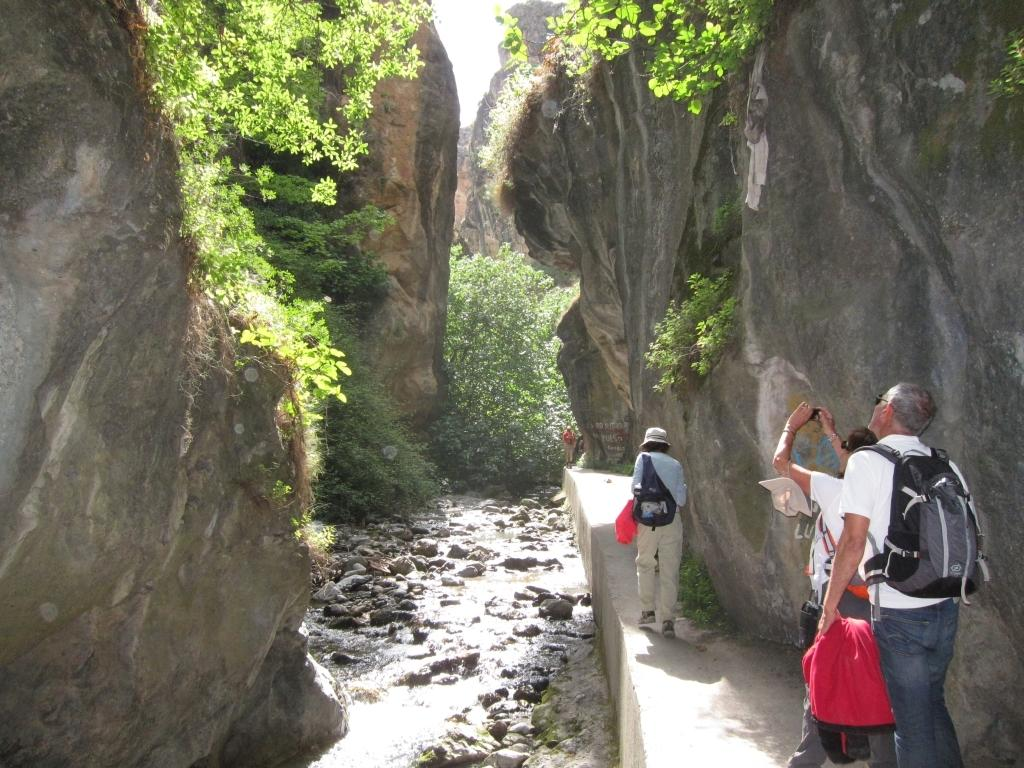What type of natural formations can be seen in the image? There are rock hills in the image. What other natural elements are present in the image? There are plants, stones, and trees in the image. Are there any signs of human presence in the image? Yes, there are people visible on a path in the image. What can be seen in the sky in the image? The sky is visible in the image. What type of popcorn is being sold by the vendor in the image? There is no vendor or popcorn present in the image. How much payment is required for the vessel in the image? There is no vessel or payment mentioned in the image. 